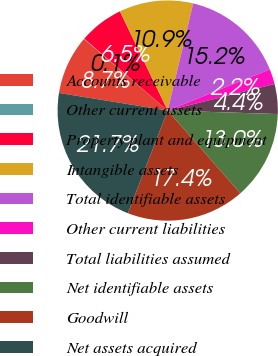Convert chart to OTSL. <chart><loc_0><loc_0><loc_500><loc_500><pie_chart><fcel>Accounts receivable<fcel>Other current assets<fcel>Property plant and equipment<fcel>Intangible assets<fcel>Total identifiable assets<fcel>Other current liabilities<fcel>Total liabilities assumed<fcel>Net identifiable assets<fcel>Goodwill<fcel>Net assets acquired<nl><fcel>8.7%<fcel>0.06%<fcel>6.54%<fcel>10.86%<fcel>15.19%<fcel>2.22%<fcel>4.38%<fcel>13.03%<fcel>17.35%<fcel>21.67%<nl></chart> 